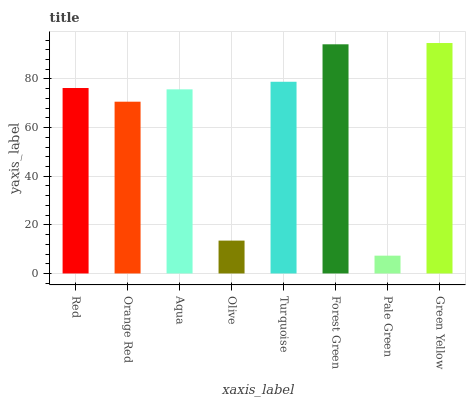Is Pale Green the minimum?
Answer yes or no. Yes. Is Green Yellow the maximum?
Answer yes or no. Yes. Is Orange Red the minimum?
Answer yes or no. No. Is Orange Red the maximum?
Answer yes or no. No. Is Red greater than Orange Red?
Answer yes or no. Yes. Is Orange Red less than Red?
Answer yes or no. Yes. Is Orange Red greater than Red?
Answer yes or no. No. Is Red less than Orange Red?
Answer yes or no. No. Is Red the high median?
Answer yes or no. Yes. Is Aqua the low median?
Answer yes or no. Yes. Is Olive the high median?
Answer yes or no. No. Is Olive the low median?
Answer yes or no. No. 